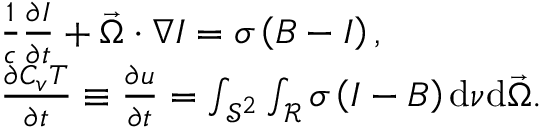Convert formula to latex. <formula><loc_0><loc_0><loc_500><loc_500>\begin{array} { r l } & { \frac { 1 } { c } \frac { \partial I } { \partial t } + \vec { \Omega } \cdot \nabla I = \sigma \left ( B - I \right ) , } \\ & { \frac { \partial C _ { v } T } { \partial t } \equiv \frac { \partial u } { \partial t } = \int _ { \mathcal { S } ^ { 2 } } \int _ { \mathcal { R } } \sigma \left ( I - B \right ) d \nu d \vec { \Omega } . } \end{array}</formula> 